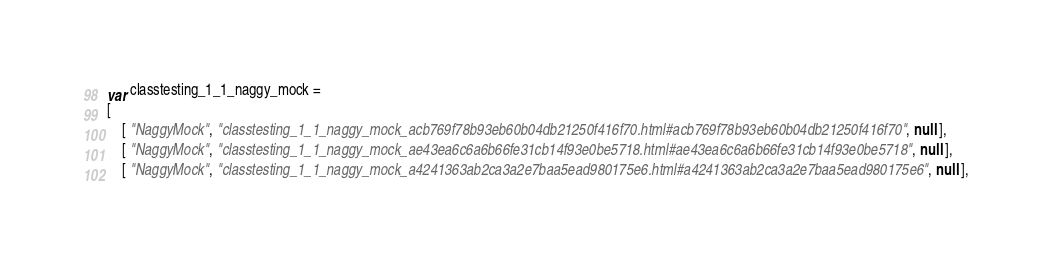<code> <loc_0><loc_0><loc_500><loc_500><_JavaScript_>var classtesting_1_1_naggy_mock =
[
    [ "NaggyMock", "classtesting_1_1_naggy_mock_acb769f78b93eb60b04db21250f416f70.html#acb769f78b93eb60b04db21250f416f70", null ],
    [ "NaggyMock", "classtesting_1_1_naggy_mock_ae43ea6c6a6b66fe31cb14f93e0be5718.html#ae43ea6c6a6b66fe31cb14f93e0be5718", null ],
    [ "NaggyMock", "classtesting_1_1_naggy_mock_a4241363ab2ca3a2e7baa5ead980175e6.html#a4241363ab2ca3a2e7baa5ead980175e6", null ],</code> 